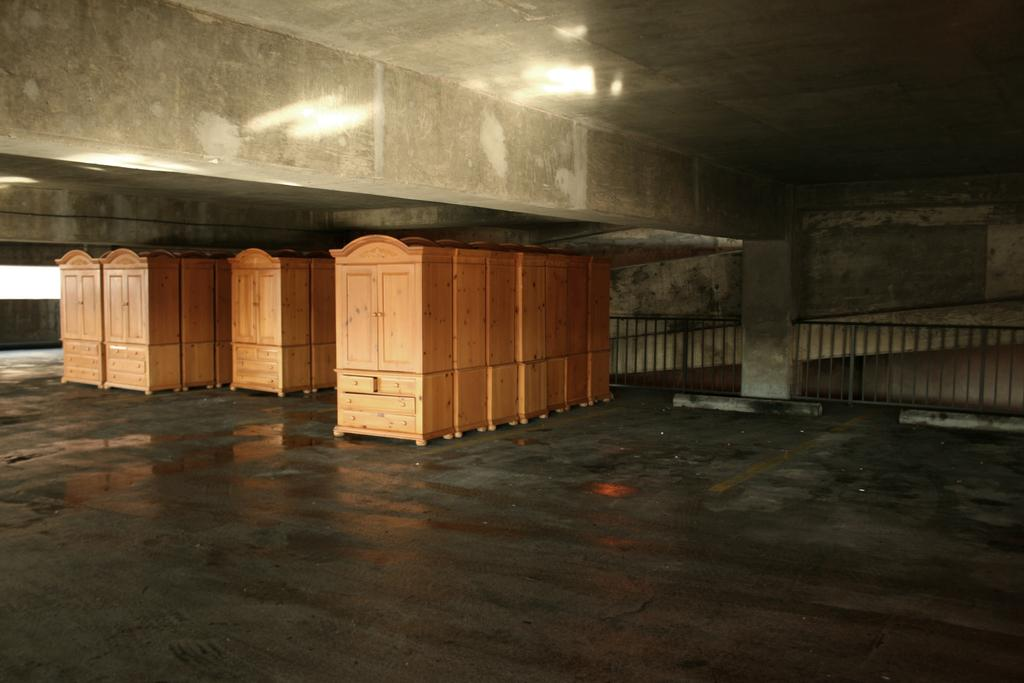What type of structure can be seen in the image? There are shelves, a pillar, and railing in the image. Can you describe the pillar in the image? There is a pillar in the back of the image. What might the railing be used for in the image? The railing in the image could be used for support or as a safety feature. What type of story is being told by the button in the image? There is no button present in the image, so no story can be told by it. 